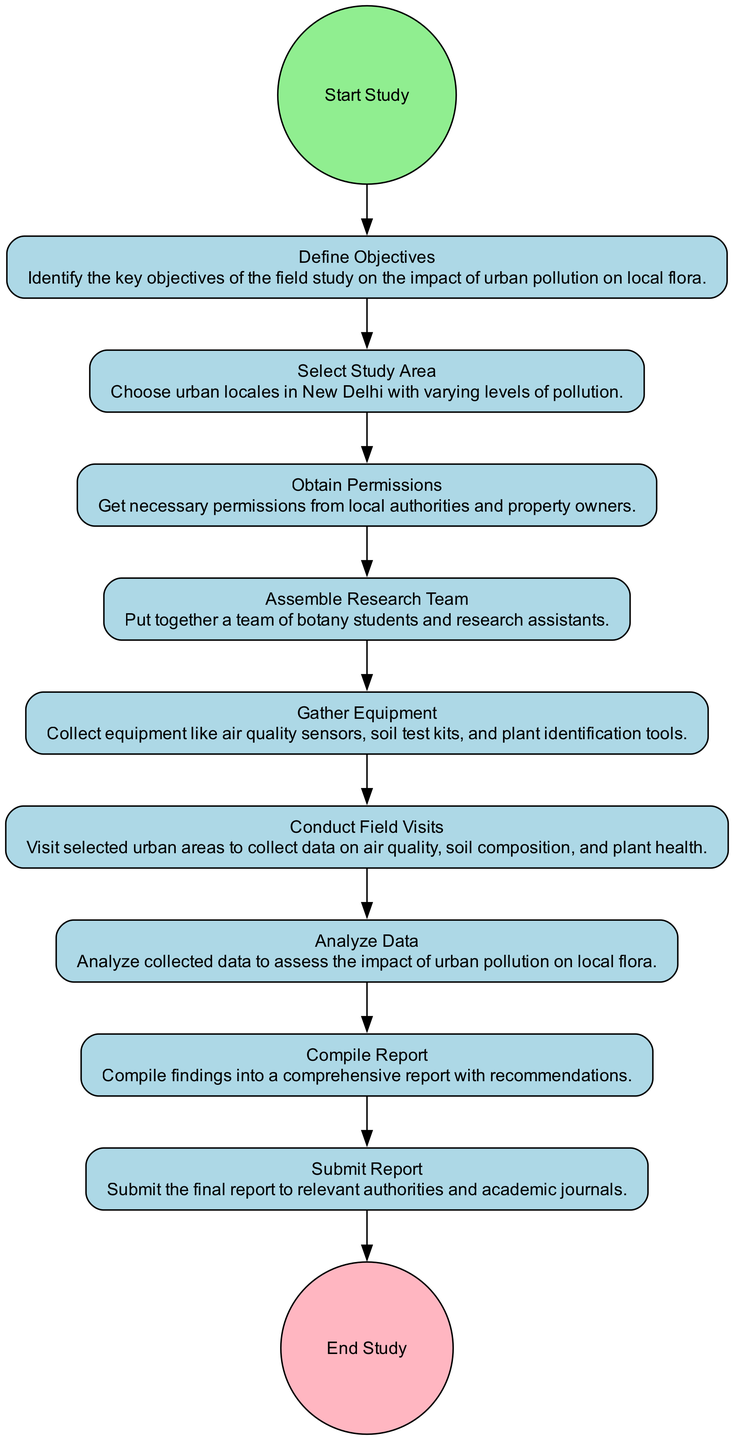What is the first activity in the diagram? The first activity in the diagram is labeled "Start Study." This is identified by the very first node, which is the starting point of the entire field study process.
Answer: Start Study How many activities are there in total? Counting the nodes in the diagram that represent activities, we find that there are 8 activities from "Define Objectives" to "Submit Report."
Answer: 8 What is the last activity before ending the study? The last activity before reaching the "End Study" node is "Submit Report." This can be determined by identifying the node that comes immediately before the final end node.
Answer: Submit Report What type of nodes are connected by edges in the diagram? The edges in the diagram connect "StartEvent," "Activity," and "EndEvent" nodes, showing the flow of the study. Each connection directs from one activity to the next until the study concludes.
Answer: StartEvent, Activity, EndEvent After selecting a study area, what is the next action? The next action after "Select Study Area" is "Obtain Permissions." This can be seen by following the flow from the "Select Study Area" node to the following node in the sequence.
Answer: Obtain Permissions Which activity involves analyzing collected data? The activity that involves analyzing collected data is "Analyze Data." This is specifically mentioned in the description of its corresponding node in the diagram.
Answer: Analyze Data How many edges are there in the diagram? By counting the connections (edges) between the nodes, we see that there are 9 edges, as each activity flows into the next.
Answer: 9 What is the purpose of "Gather Equipment"? The purpose of "Gather Equipment" is to collect necessary tools like air quality sensors and soil test kits for the study. This is explained in the description of that activity node.
Answer: Collect necessary tools What comes after "Conduct Field Visits"? Following "Conduct Field Visits," the next activity is "Analyze Data." This is identified by looking at the sequential relationship between the nodes in the diagram.
Answer: Analyze Data 